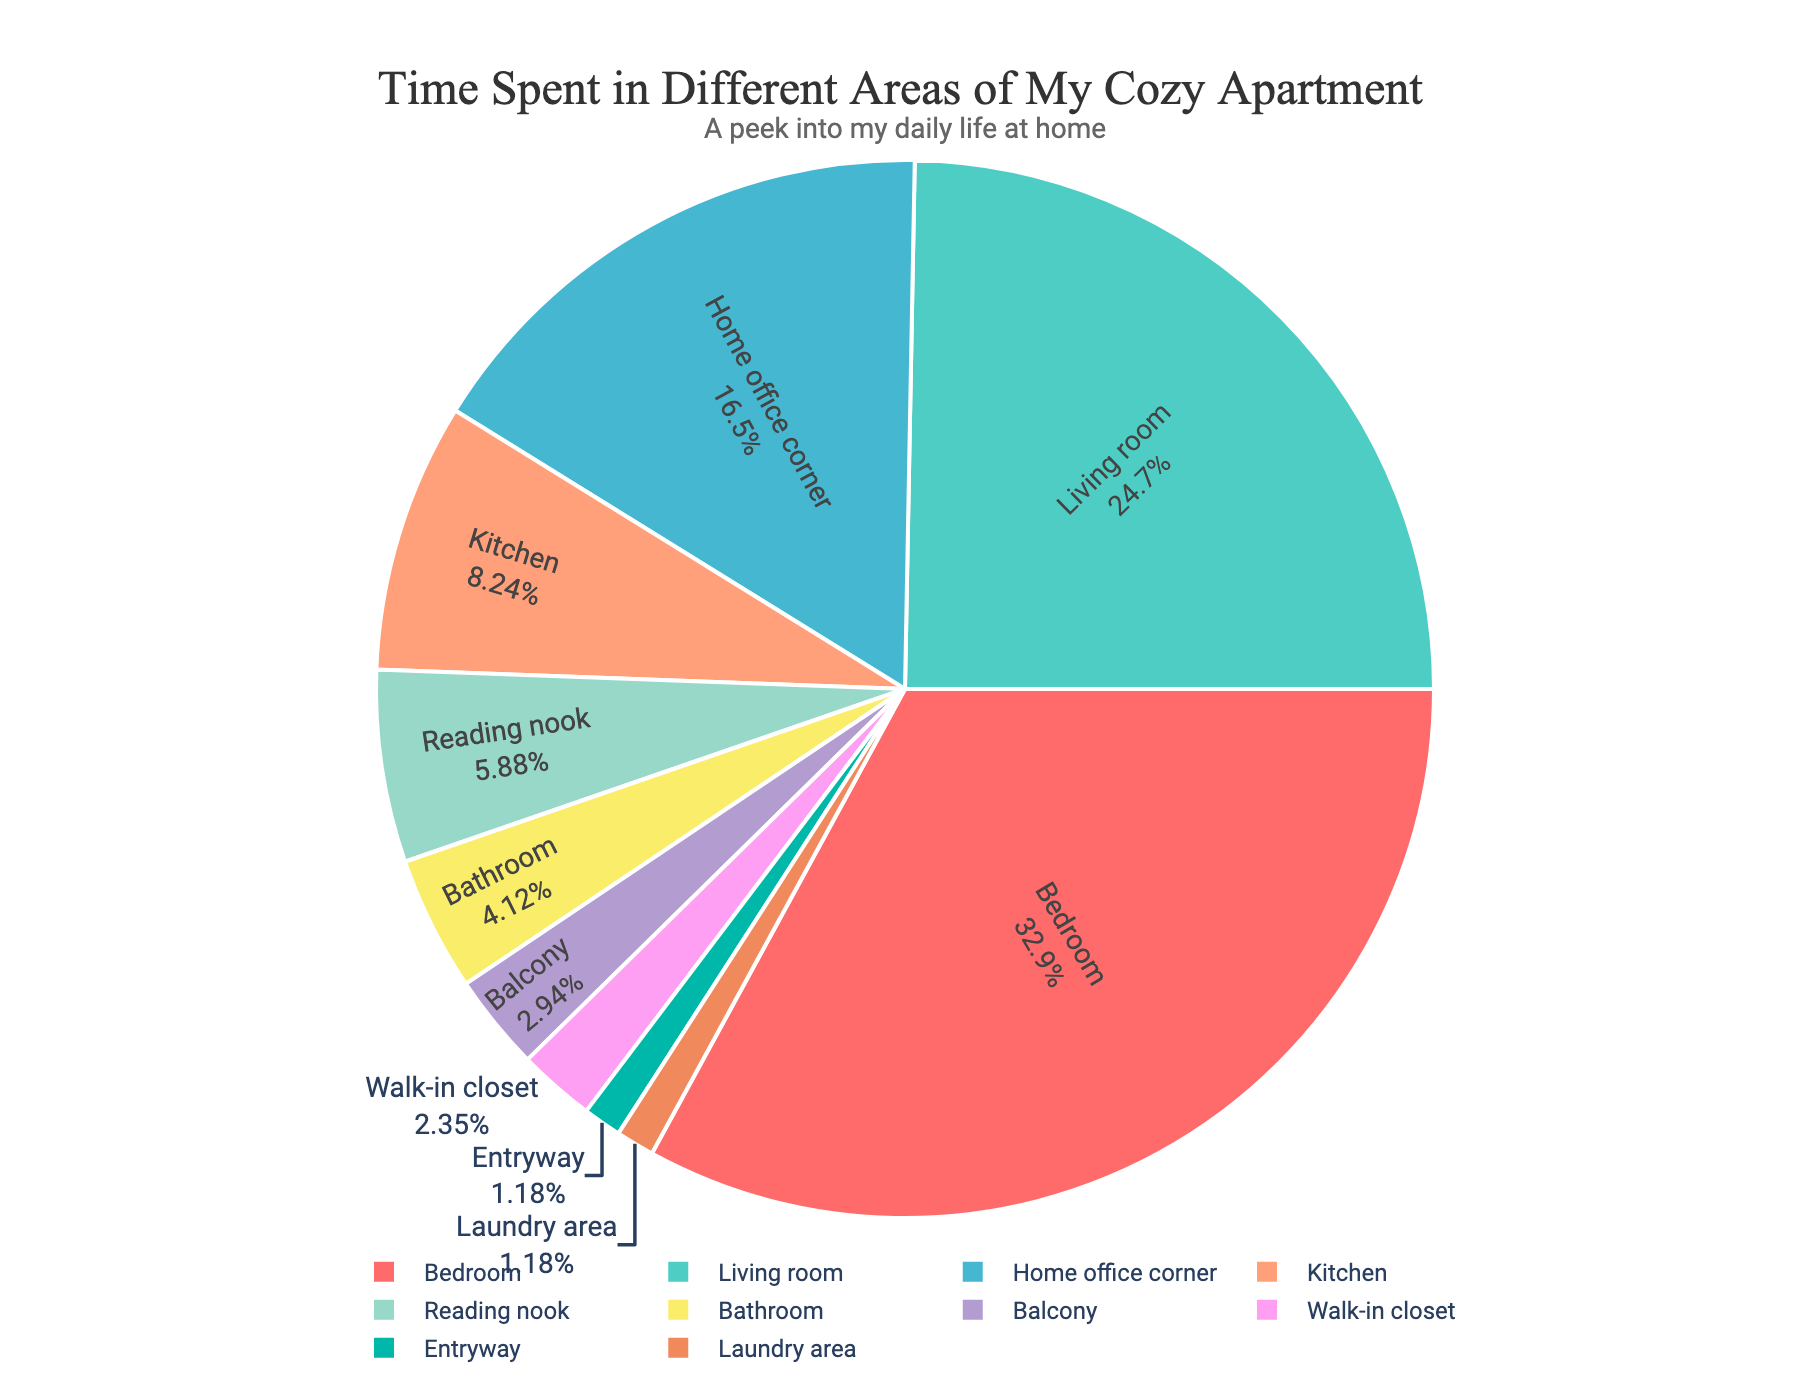What percentage of time is spent in the Bedroom? The pie chart indicates both the label and percentage for each area. The Bedroom shows the accompanying percentage.
Answer: 28% How much more time is spent in the Living room compared to the Kitchen? According to the pie chart, the Living room is labeled with 42 hours per week and the Kitchen with 14 hours per week. Subtracting 14 from 42 gives the difference.
Answer: 28 hours Which area has the least amount of time spent? The pie chart labels each section with time spent per week. The Entryway and Laundry area are the smallest, with 2 hours each.
Answer: Entryway, Laundry area Is more time spent in the Home office corner or the Reading nook? The pie chart shows the Home office corner with 28 hours and the Reading nook with 10 hours. Comparing these two values, 28 is greater than 10.
Answer: Home office corner What is the combined percentage of time spent in the Bathroom and Walk-in closet? The pie chart indicates that the Bathroom accounts for 4% (7 hours) and the Walk-in closet accounts for 2% (4 hours). Summing these percentages gives 4% + 2% = 6%.
Answer: 6% Which area has more time spent, Balcony or Bathroom? The pie chart labels the Balcony with 5 hours and the Bathroom with 7 hours. Comparing these, 7 is greater than 5.
Answer: Bathroom How much total time is spent in the Kitchen, Bathroom, and Laundry area combined? The pie chart labels the Kitchen with 14 hours, the Bathroom with 7 hours, and the Laundry area with 2 hours. Summing these values gives 14 + 7 + 2 = 23 hours.
Answer: 23 hours What are the two most time-consuming activities? The pie chart has the label for each area. Bedroom and Living room have the highest values of 56 and 42 hours, respectively.
Answer: Bedroom, Living room What is the difference in time spent between the Bedroom and the Living room? The pie chart shows 56 hours in the Bedroom and 42 hours in the Living room. Subtracting 42 from 56 gives the difference.
Answer: 14 hours Which segment has a green color, and how much time is associated with it? The pie chart uses distinct colors for each section. The green segment (usually unique) represents Home office corner, with 28 hours.
Answer: Home office corner, 28 hours 